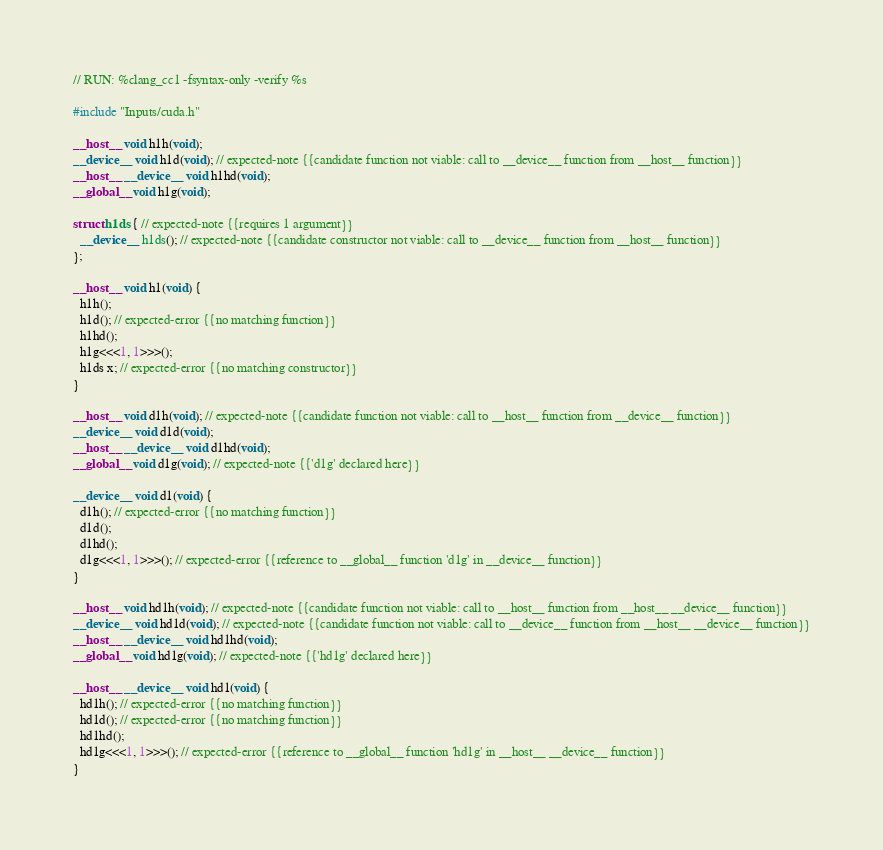<code> <loc_0><loc_0><loc_500><loc_500><_Cuda_>// RUN: %clang_cc1 -fsyntax-only -verify %s

#include "Inputs/cuda.h"

__host__ void h1h(void);
__device__ void h1d(void); // expected-note {{candidate function not viable: call to __device__ function from __host__ function}}
__host__ __device__ void h1hd(void);
__global__ void h1g(void);

struct h1ds { // expected-note {{requires 1 argument}}
  __device__ h1ds(); // expected-note {{candidate constructor not viable: call to __device__ function from __host__ function}}
};

__host__ void h1(void) {
  h1h();
  h1d(); // expected-error {{no matching function}}
  h1hd();
  h1g<<<1, 1>>>();
  h1ds x; // expected-error {{no matching constructor}}
}

__host__ void d1h(void); // expected-note {{candidate function not viable: call to __host__ function from __device__ function}}
__device__ void d1d(void);
__host__ __device__ void d1hd(void);
__global__ void d1g(void); // expected-note {{'d1g' declared here}}

__device__ void d1(void) {
  d1h(); // expected-error {{no matching function}}
  d1d();
  d1hd();
  d1g<<<1, 1>>>(); // expected-error {{reference to __global__ function 'd1g' in __device__ function}}
}

__host__ void hd1h(void); // expected-note {{candidate function not viable: call to __host__ function from __host__ __device__ function}}
__device__ void hd1d(void); // expected-note {{candidate function not viable: call to __device__ function from __host__ __device__ function}}
__host__ __device__ void hd1hd(void);
__global__ void hd1g(void); // expected-note {{'hd1g' declared here}}

__host__ __device__ void hd1(void) {
  hd1h(); // expected-error {{no matching function}}
  hd1d(); // expected-error {{no matching function}}
  hd1hd();
  hd1g<<<1, 1>>>(); // expected-error {{reference to __global__ function 'hd1g' in __host__ __device__ function}}
}
</code> 